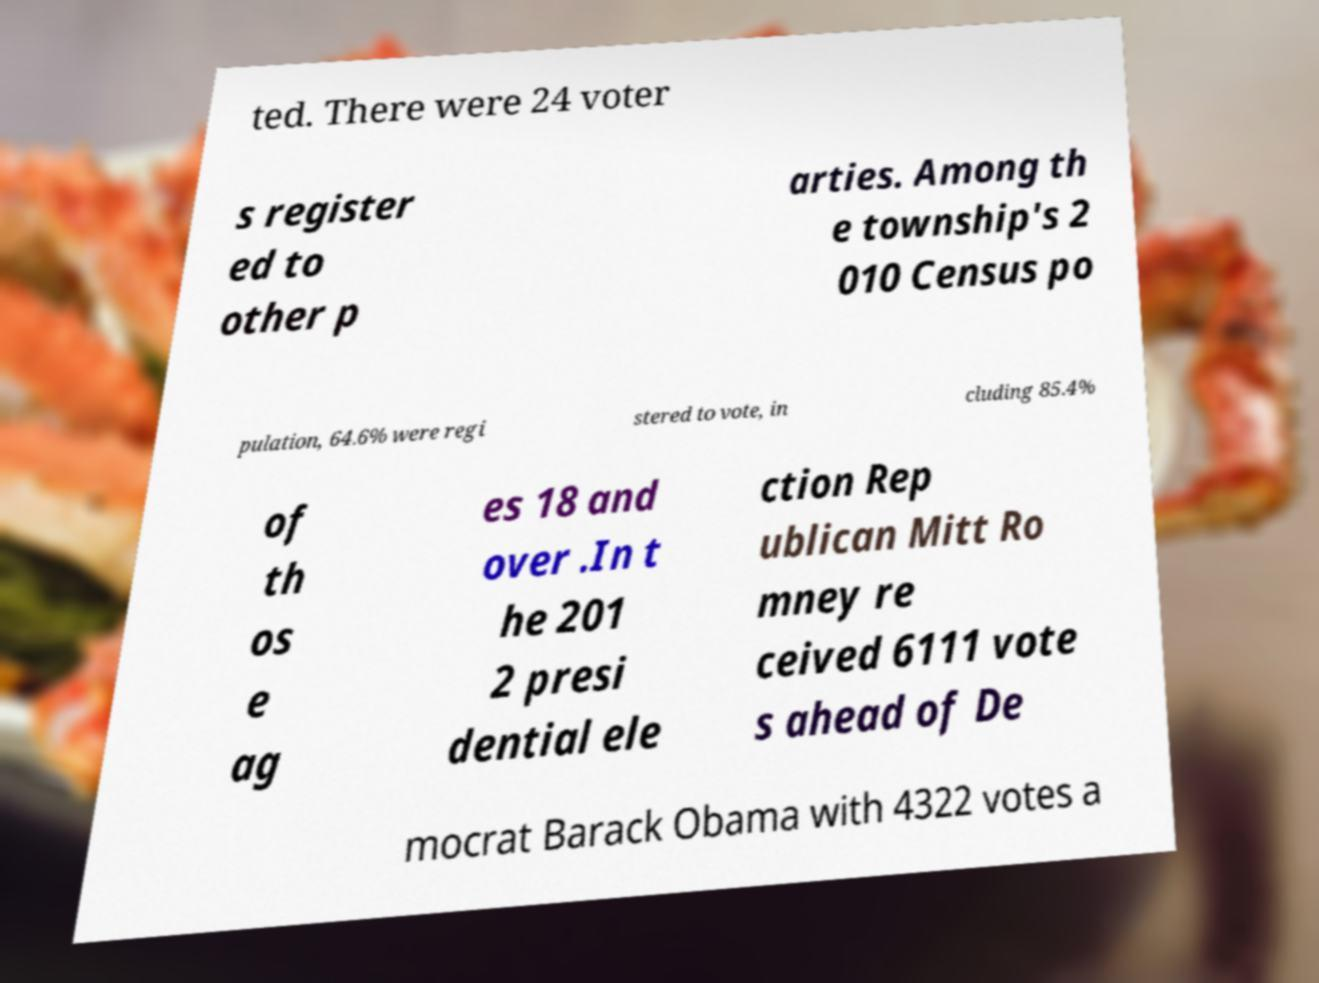There's text embedded in this image that I need extracted. Can you transcribe it verbatim? ted. There were 24 voter s register ed to other p arties. Among th e township's 2 010 Census po pulation, 64.6% were regi stered to vote, in cluding 85.4% of th os e ag es 18 and over .In t he 201 2 presi dential ele ction Rep ublican Mitt Ro mney re ceived 6111 vote s ahead of De mocrat Barack Obama with 4322 votes a 